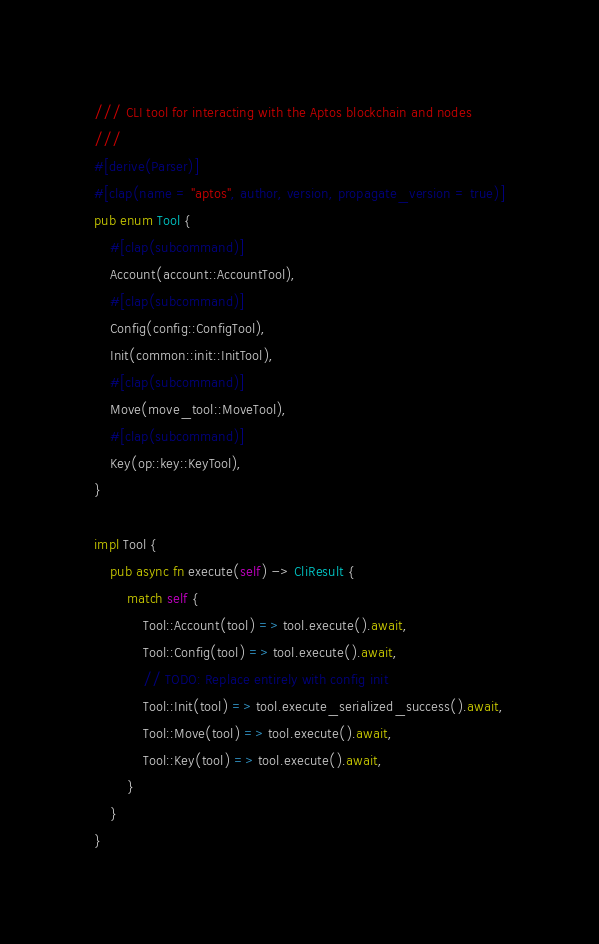Convert code to text. <code><loc_0><loc_0><loc_500><loc_500><_Rust_>/// CLI tool for interacting with the Aptos blockchain and nodes
///
#[derive(Parser)]
#[clap(name = "aptos", author, version, propagate_version = true)]
pub enum Tool {
    #[clap(subcommand)]
    Account(account::AccountTool),
    #[clap(subcommand)]
    Config(config::ConfigTool),
    Init(common::init::InitTool),
    #[clap(subcommand)]
    Move(move_tool::MoveTool),
    #[clap(subcommand)]
    Key(op::key::KeyTool),
}

impl Tool {
    pub async fn execute(self) -> CliResult {
        match self {
            Tool::Account(tool) => tool.execute().await,
            Tool::Config(tool) => tool.execute().await,
            // TODO: Replace entirely with config init
            Tool::Init(tool) => tool.execute_serialized_success().await,
            Tool::Move(tool) => tool.execute().await,
            Tool::Key(tool) => tool.execute().await,
        }
    }
}
</code> 